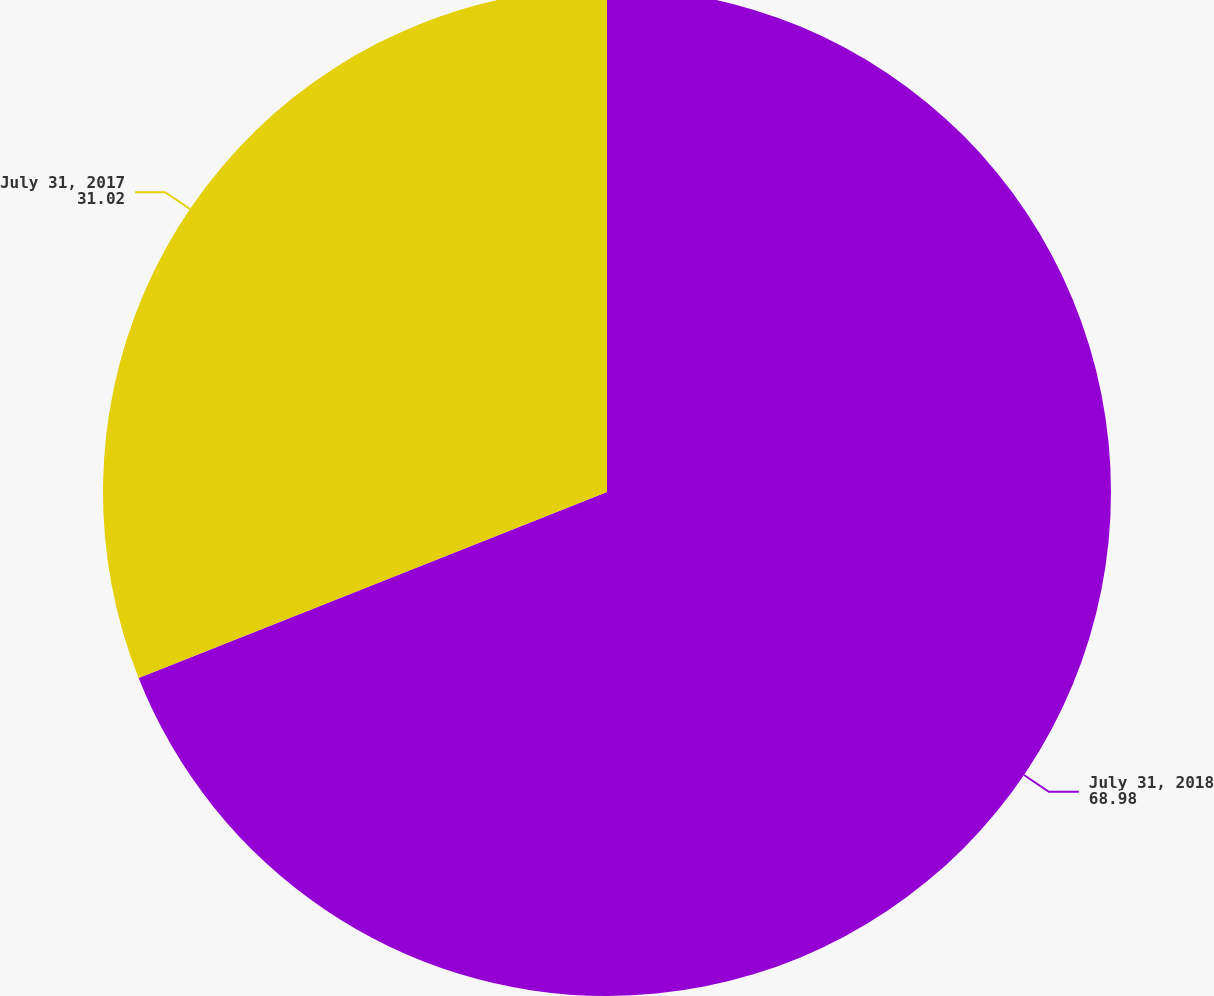<chart> <loc_0><loc_0><loc_500><loc_500><pie_chart><fcel>July 31, 2018<fcel>July 31, 2017<nl><fcel>68.98%<fcel>31.02%<nl></chart> 